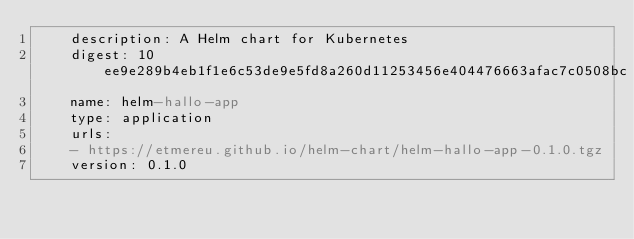<code> <loc_0><loc_0><loc_500><loc_500><_YAML_>    description: A Helm chart for Kubernetes
    digest: 10ee9e289b4eb1f1e6c53de9e5fd8a260d11253456e404476663afac7c0508bc
    name: helm-hallo-app
    type: application
    urls:
    - https://etmereu.github.io/helm-chart/helm-hallo-app-0.1.0.tgz
    version: 0.1.0</code> 